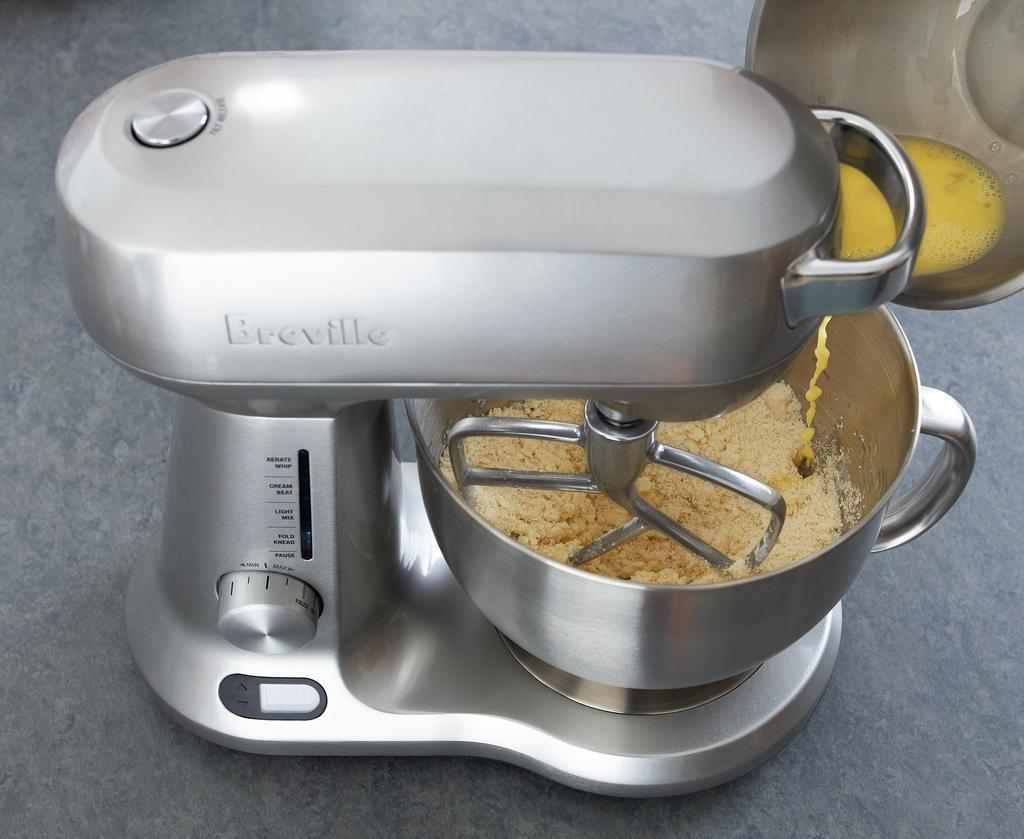<image>
Write a terse but informative summary of the picture. A Breville brand mixer with beaters in cake batter. 